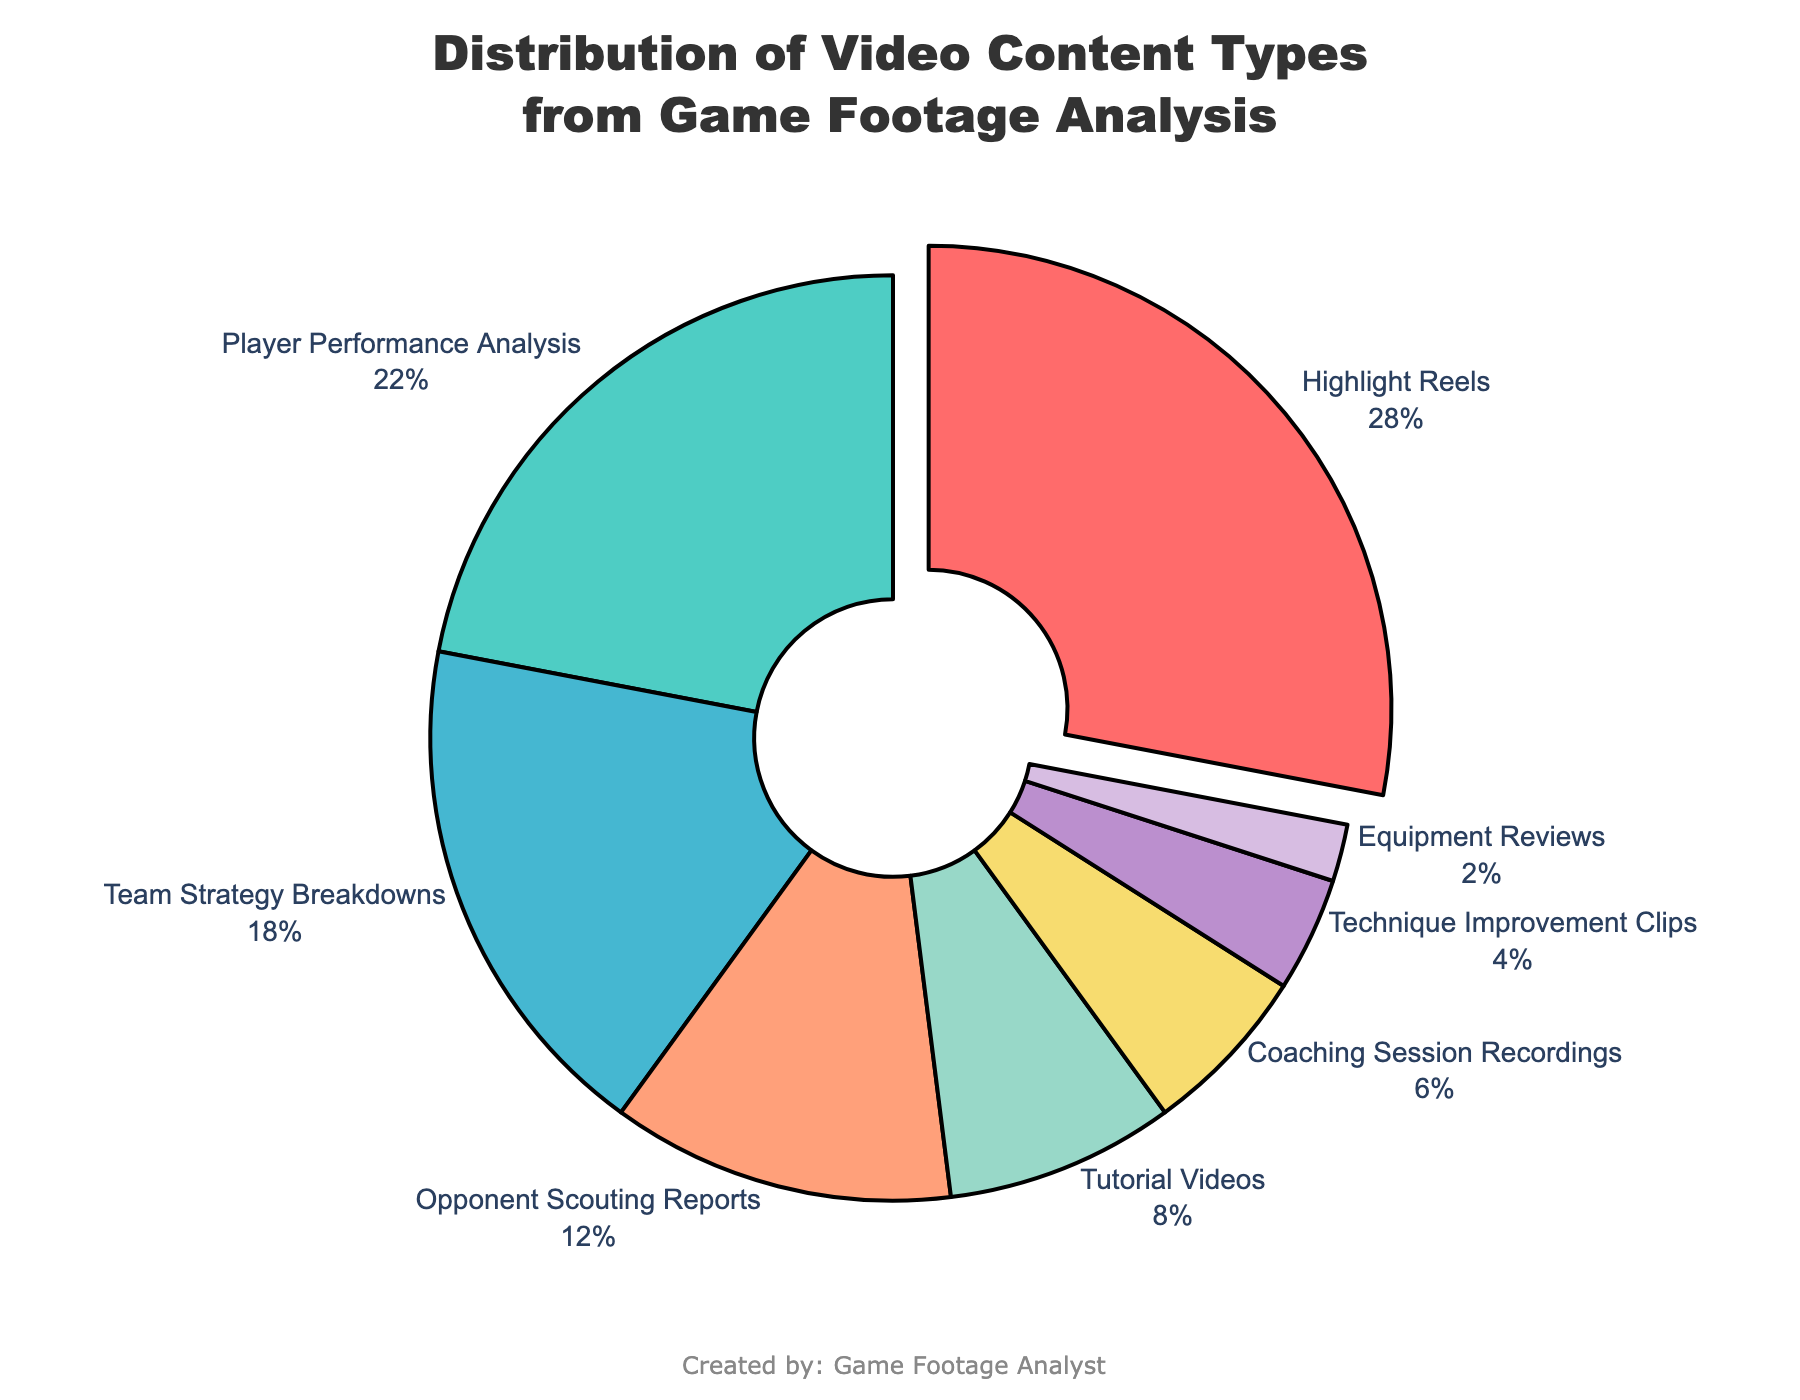What type of video content occupies the largest portion of the pie chart? The largest portion of the pie chart is pulled out slightly for emphasis, and the label indicates it is "Highlight Reels" with 28%.
Answer: Highlight Reels What is the combined percentage of Player Performance Analysis and Team Strategy Breakdowns? The percentage for Player Performance Analysis is 22% and for Team Strategy Breakdowns is 18%. Adding these together gives 22 + 18 = 40%.
Answer: 40% Is the percentage of Tutorial Videos greater than the percentage of Opponent Scouting Reports? The percentage of Tutorial Videos is 8%, and the percentage of Opponent Scouting Reports is 12%. 8% is less than 12%.
Answer: No How many types of content have a percentage lower than 10%? The types of content with percentages lower than 10% are Tutorial Videos (8%), Coaching Session Recordings (6%), Technique Improvement Clips (4%), and Equipment Reviews (2%). There are four types in total.
Answer: 4 What is the difference between the percentages of Highlight Reels and Player Performance Analysis? The percentage of Highlight Reels is 28% and that of Player Performance Analysis is 22%. The difference is 28 - 22 = 6%.
Answer: 6% What content type uses blue color in the pie chart? The blue color corresponds to the segment labeled "Opponent Scouting Reports."
Answer: Opponent Scouting Reports What percentage total do Technique Improvement Clips and Equipment Reviews make up together? The percentage for Technique Improvement Clips is 4%, and for Equipment Reviews, it is 2%. Adding these together gives 4 + 2 = 6%.
Answer: 6% Is Coaching Session Recordings the second smallest or third smallest content type in terms of percentage? The smallest is Equipment Reviews (2%), followed by Technique Improvement Clips (4%), so Coaching Session Recordings (6%) is the third smallest.
Answer: Third smallest Which video content type is represented by green color? The green color corresponds to the segment labeled "Player Performance Analysis."
Answer: Player Performance Analysis What's the sum of the percentages of the three smallest video content types? The three smallest video content types are Equipment Reviews (2%), Technique Improvement Clips (4%), and Coaching Session Recordings (6%). Adding these together gives 2 + 4 + 6 = 12%.
Answer: 12% 